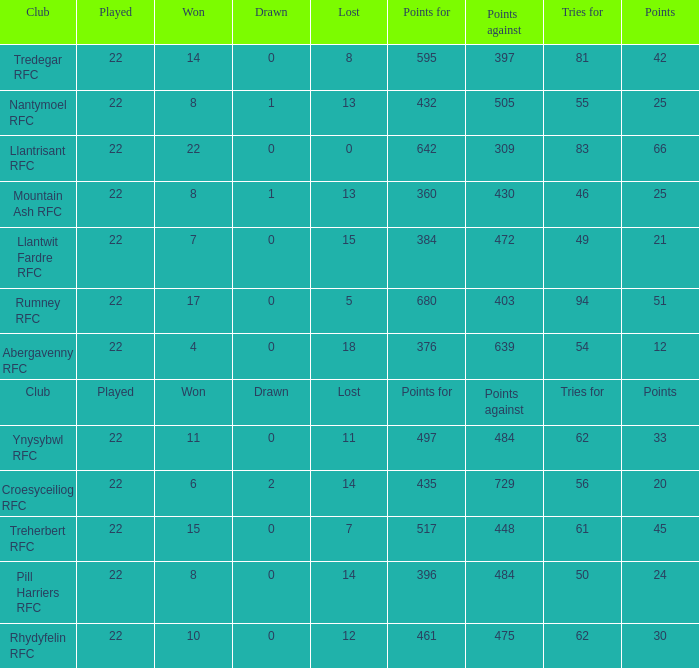How many tries for were scored by the team that had exactly 396 points for? 50.0. 